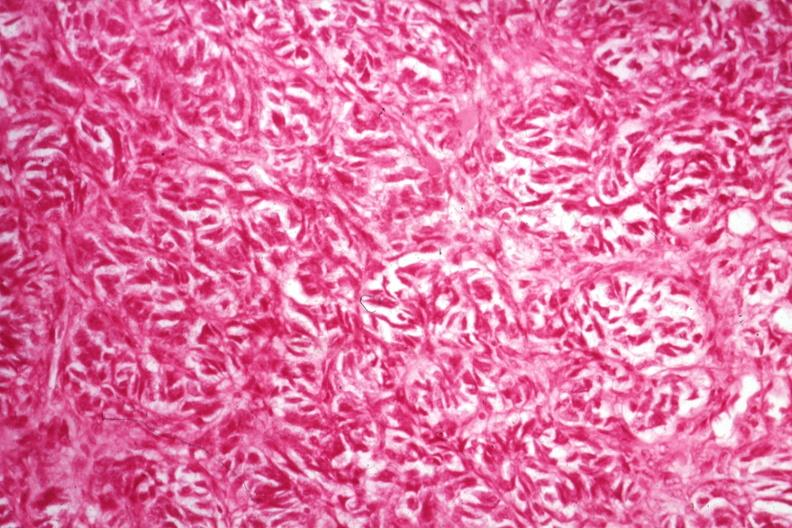s acid present?
Answer the question using a single word or phrase. No 